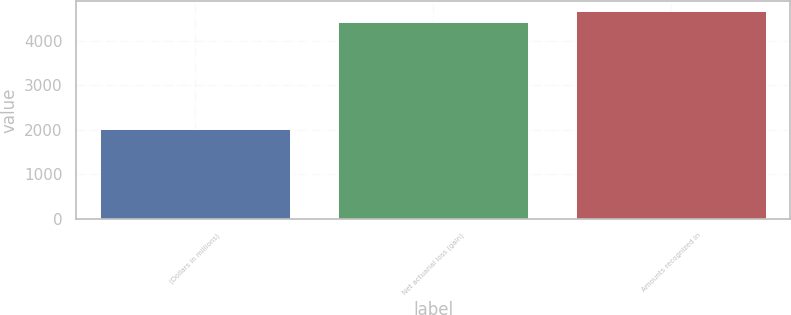Convert chart. <chart><loc_0><loc_0><loc_500><loc_500><bar_chart><fcel>(Dollars in millions)<fcel>Net actuarial loss (gain)<fcel>Amounts recognized in<nl><fcel>2016<fcel>4429<fcel>4670.3<nl></chart> 